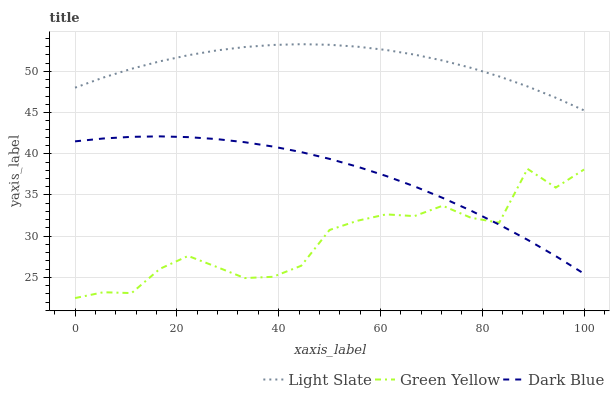Does Green Yellow have the minimum area under the curve?
Answer yes or no. Yes. Does Light Slate have the maximum area under the curve?
Answer yes or no. Yes. Does Dark Blue have the minimum area under the curve?
Answer yes or no. No. Does Dark Blue have the maximum area under the curve?
Answer yes or no. No. Is Dark Blue the smoothest?
Answer yes or no. Yes. Is Green Yellow the roughest?
Answer yes or no. Yes. Is Green Yellow the smoothest?
Answer yes or no. No. Is Dark Blue the roughest?
Answer yes or no. No. Does Green Yellow have the lowest value?
Answer yes or no. Yes. Does Dark Blue have the lowest value?
Answer yes or no. No. Does Light Slate have the highest value?
Answer yes or no. Yes. Does Dark Blue have the highest value?
Answer yes or no. No. Is Dark Blue less than Light Slate?
Answer yes or no. Yes. Is Light Slate greater than Dark Blue?
Answer yes or no. Yes. Does Dark Blue intersect Green Yellow?
Answer yes or no. Yes. Is Dark Blue less than Green Yellow?
Answer yes or no. No. Is Dark Blue greater than Green Yellow?
Answer yes or no. No. Does Dark Blue intersect Light Slate?
Answer yes or no. No. 